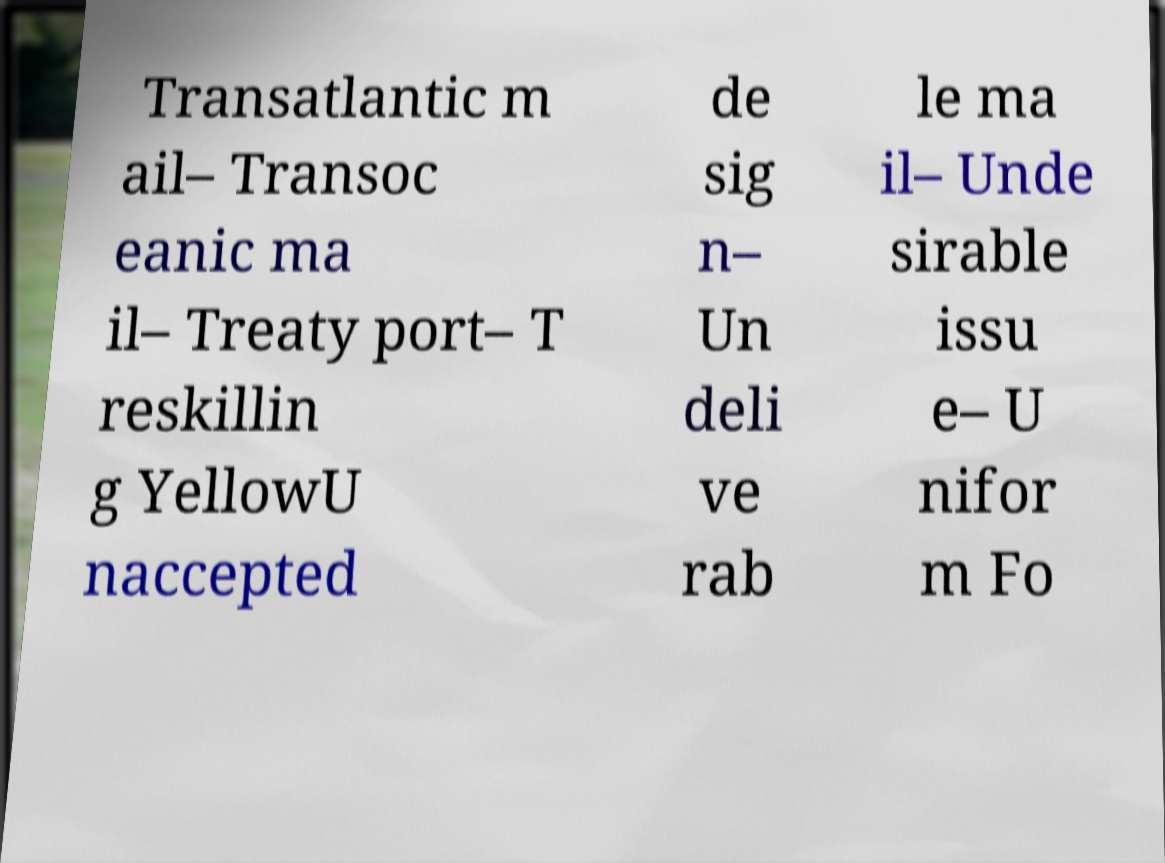What messages or text are displayed in this image? I need them in a readable, typed format. Transatlantic m ail– Transoc eanic ma il– Treaty port– T reskillin g YellowU naccepted de sig n– Un deli ve rab le ma il– Unde sirable issu e– U nifor m Fo 